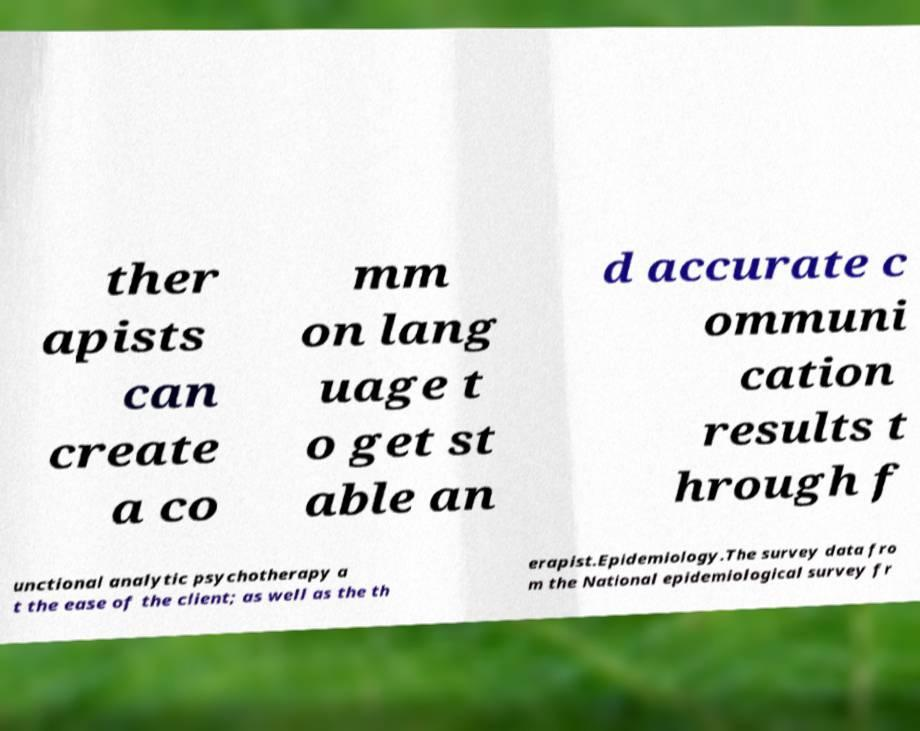Could you extract and type out the text from this image? ther apists can create a co mm on lang uage t o get st able an d accurate c ommuni cation results t hrough f unctional analytic psychotherapy a t the ease of the client; as well as the th erapist.Epidemiology.The survey data fro m the National epidemiological survey fr 